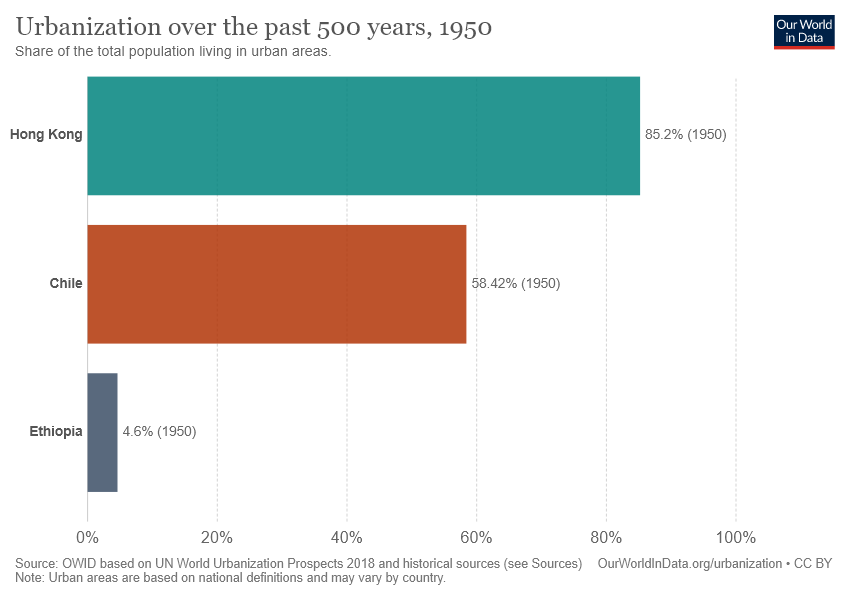Give some essential details in this illustration. The smallest bar has a value of 4.6. 